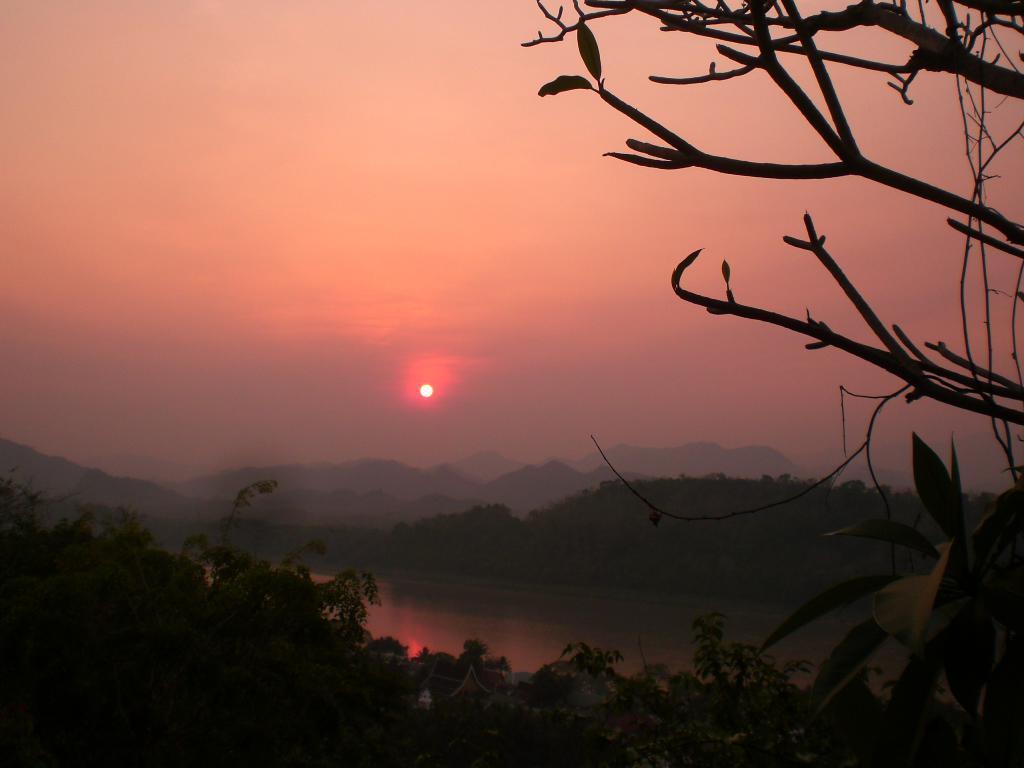How would you summarize this image in a sentence or two? In this picture we can see trees, houses and water. In the background of the image we can see hills and sky. On the right side of the image we can see leaves and branches. 